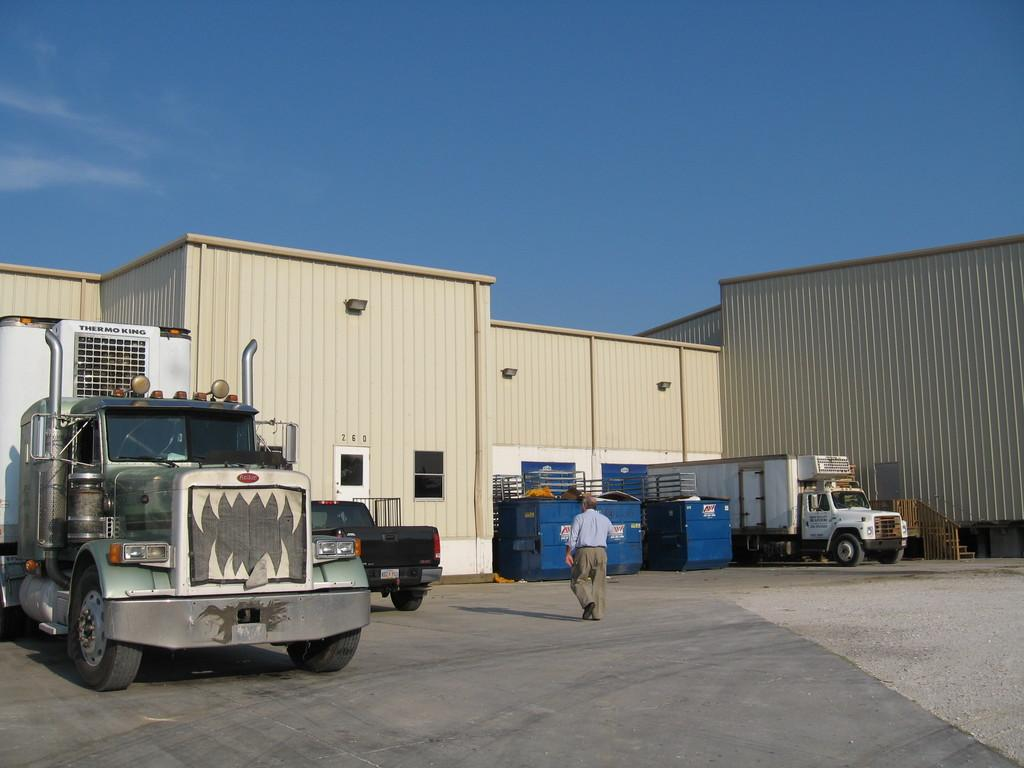What is the main subject in the foreground of the image? There is a truck in the foreground of the image. Where is the truck located in the image? The truck is on the left side of the image. What is happening in the background of the image? There is a man walking in the background of the image, and there are vehicles and at least one building visible. What is the man walking on in the background of the image? The man is walking on the ground in the background of the image. What part of the natural environment is visible in the background of the image? The sky is visible in the background of the image. What type of honey is being produced by the snails in the image? There are no snails or honey present in the image. What type of machine is being used to manufacture the vehicles in the background? There is no machine visible in the image, and the vehicles in the background are not being manufactured in the scene. 